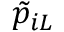Convert formula to latex. <formula><loc_0><loc_0><loc_500><loc_500>\tilde { p } _ { i L }</formula> 